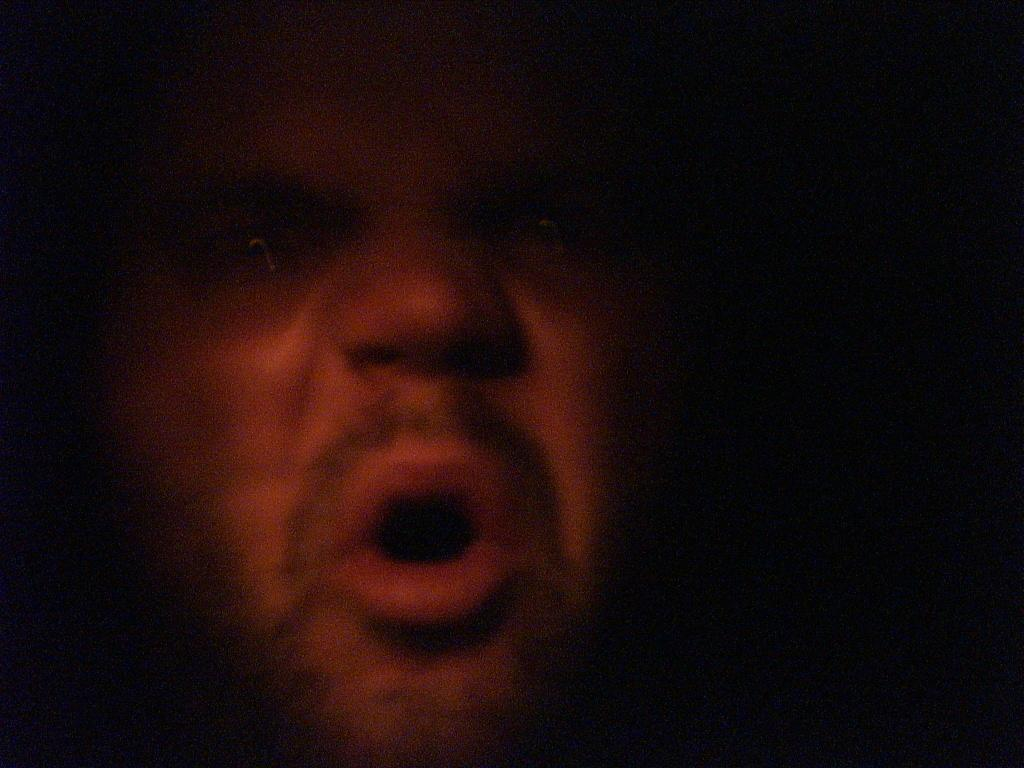What is the main subject of the image? There is a face of a person in the image. What type of plate is being used for dinner in the image? There is no plate or dinner present in the image; it only features the face of a person. What health benefits can be observed from the person's face in the image? There is no information about the person's health in the image, as it only shows their face. 